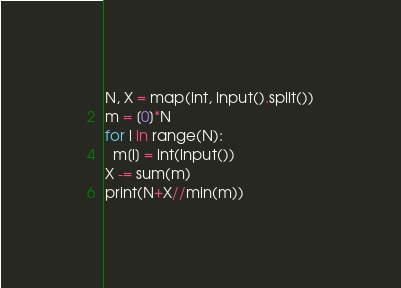<code> <loc_0><loc_0><loc_500><loc_500><_Python_>N, X = map(int, input().split())
m = [0]*N
for i in range(N):
  m[i] = int(input())
X -= sum(m)
print(N+X//min(m))</code> 